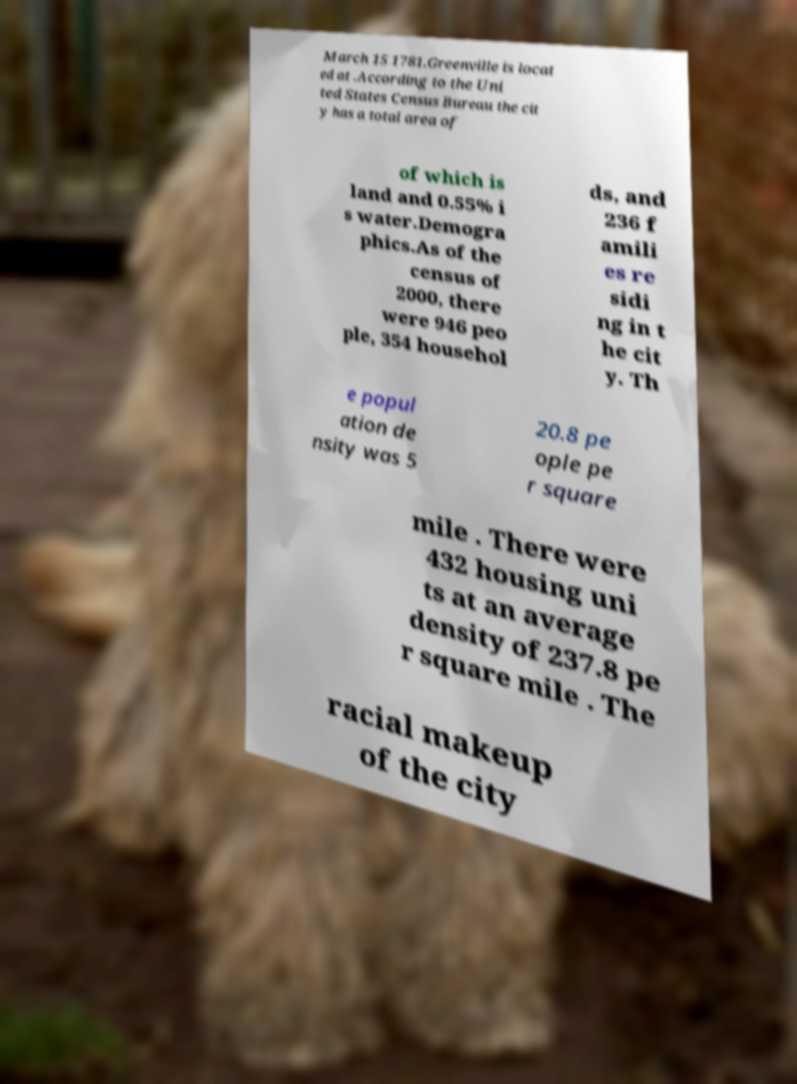Please identify and transcribe the text found in this image. March 15 1781.Greenville is locat ed at .According to the Uni ted States Census Bureau the cit y has a total area of of which is land and 0.55% i s water.Demogra phics.As of the census of 2000, there were 946 peo ple, 354 househol ds, and 236 f amili es re sidi ng in t he cit y. Th e popul ation de nsity was 5 20.8 pe ople pe r square mile . There were 432 housing uni ts at an average density of 237.8 pe r square mile . The racial makeup of the city 